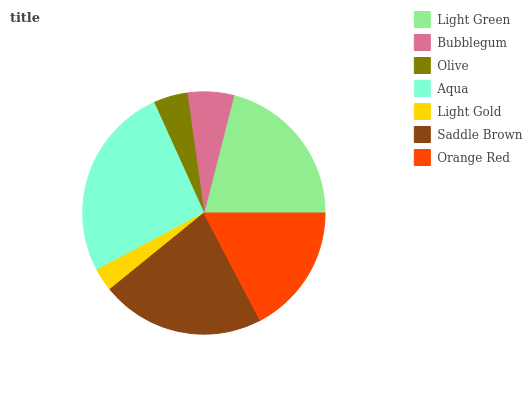Is Light Gold the minimum?
Answer yes or no. Yes. Is Aqua the maximum?
Answer yes or no. Yes. Is Bubblegum the minimum?
Answer yes or no. No. Is Bubblegum the maximum?
Answer yes or no. No. Is Light Green greater than Bubblegum?
Answer yes or no. Yes. Is Bubblegum less than Light Green?
Answer yes or no. Yes. Is Bubblegum greater than Light Green?
Answer yes or no. No. Is Light Green less than Bubblegum?
Answer yes or no. No. Is Orange Red the high median?
Answer yes or no. Yes. Is Orange Red the low median?
Answer yes or no. Yes. Is Olive the high median?
Answer yes or no. No. Is Light Green the low median?
Answer yes or no. No. 